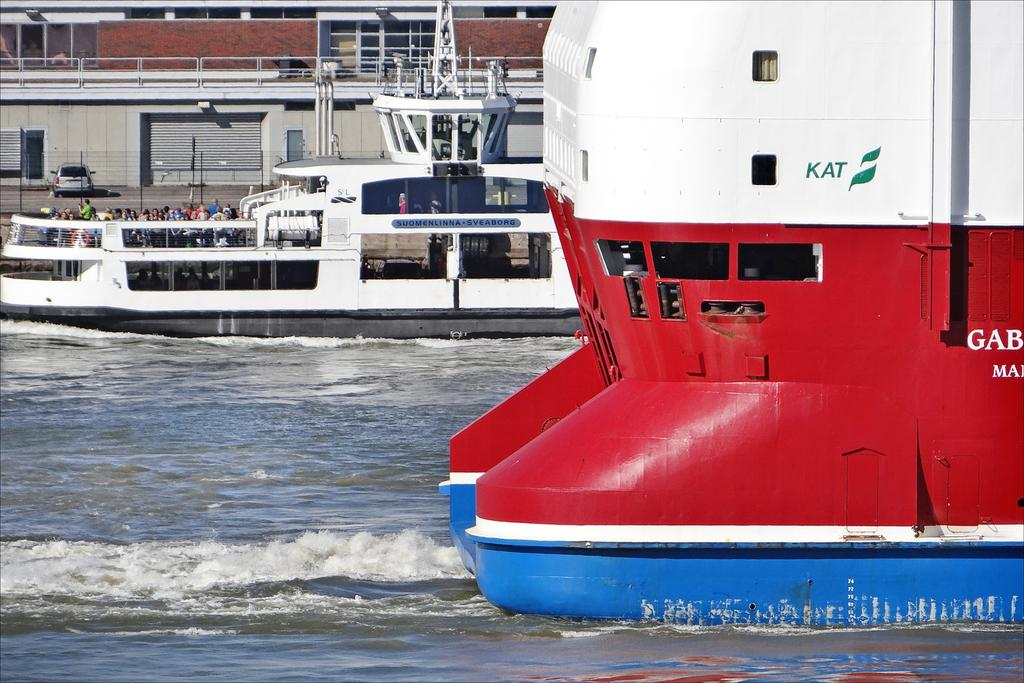<image>
Give a short and clear explanation of the subsequent image. Red, white, and blue ship that has the word KAT on it. 